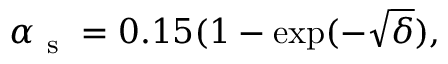Convert formula to latex. <formula><loc_0><loc_0><loc_500><loc_500>\alpha _ { s } = 0 . 1 5 ( 1 - \exp ( - \sqrt { \delta } ) ,</formula> 